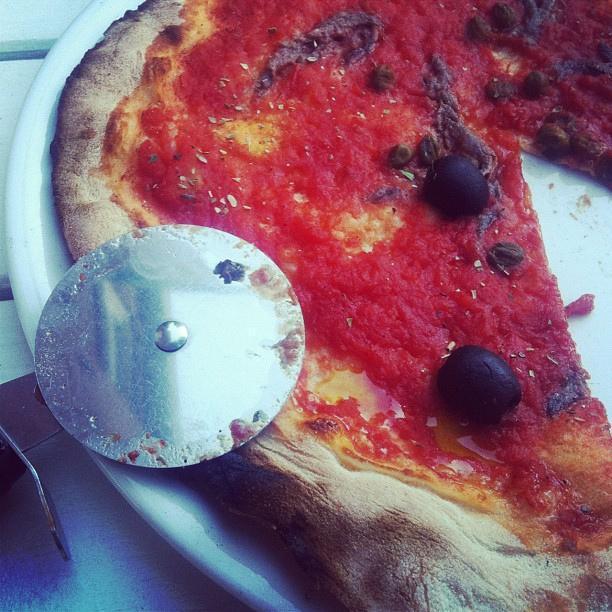How many teddy bears are there?
Give a very brief answer. 0. 